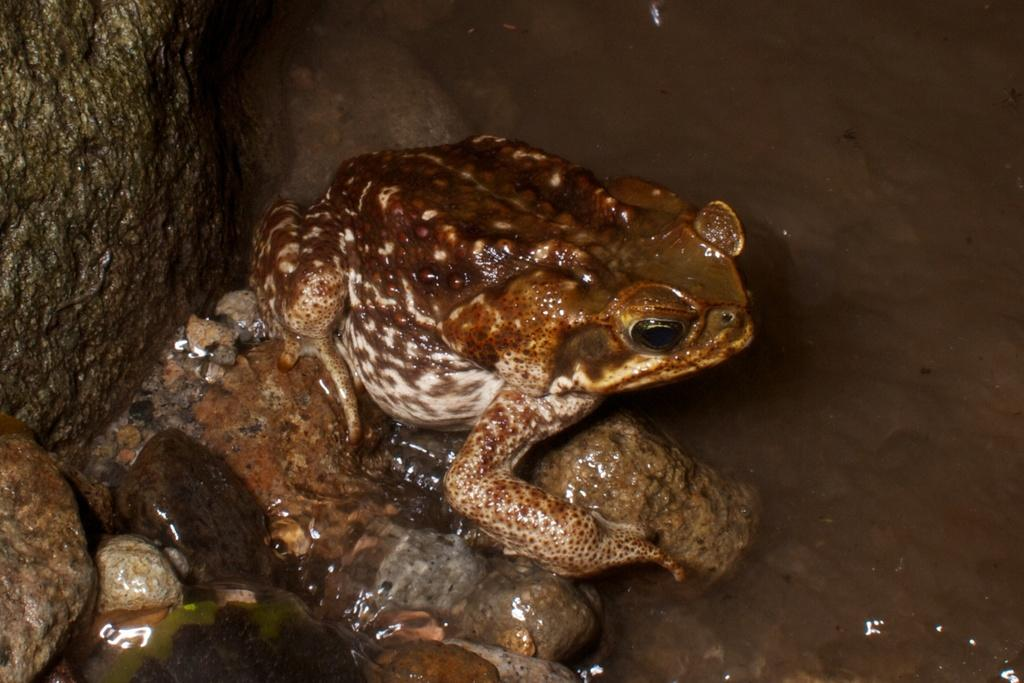What animal is present in the image? There is a frog in the image. Where is the frog located? The frog is in the water. What else can be seen in the image besides the frog? There are stones visible in the image. What colors can be observed on the frog? The frog is brown and white in color. What is the title of the book the frog is reading in the image? There is no book present in the image, and therefore no title can be identified. 